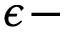Convert formula to latex. <formula><loc_0><loc_0><loc_500><loc_500>\epsilon -</formula> 